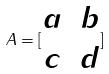<formula> <loc_0><loc_0><loc_500><loc_500>A = [ \begin{matrix} a & b \\ c & d \end{matrix} ]</formula> 